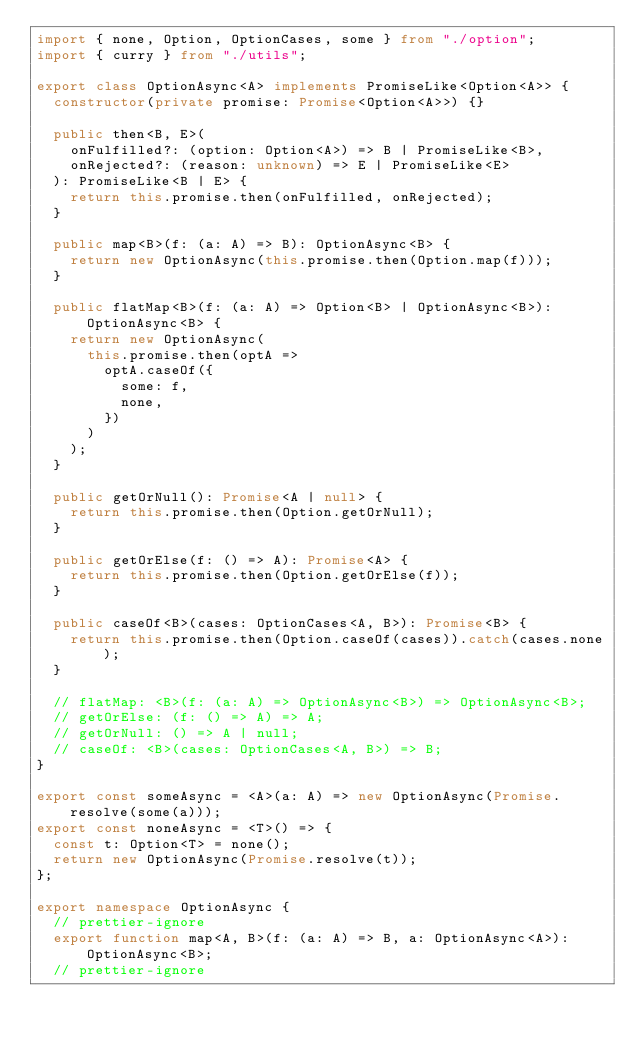Convert code to text. <code><loc_0><loc_0><loc_500><loc_500><_TypeScript_>import { none, Option, OptionCases, some } from "./option";
import { curry } from "./utils";

export class OptionAsync<A> implements PromiseLike<Option<A>> {
  constructor(private promise: Promise<Option<A>>) {}

  public then<B, E>(
    onFulfilled?: (option: Option<A>) => B | PromiseLike<B>,
    onRejected?: (reason: unknown) => E | PromiseLike<E>
  ): PromiseLike<B | E> {
    return this.promise.then(onFulfilled, onRejected);
  }

  public map<B>(f: (a: A) => B): OptionAsync<B> {
    return new OptionAsync(this.promise.then(Option.map(f)));
  }

  public flatMap<B>(f: (a: A) => Option<B> | OptionAsync<B>): OptionAsync<B> {
    return new OptionAsync(
      this.promise.then(optA =>
        optA.caseOf({
          some: f,
          none,
        })
      )
    );
  }

  public getOrNull(): Promise<A | null> {
    return this.promise.then(Option.getOrNull);
  }

  public getOrElse(f: () => A): Promise<A> {
    return this.promise.then(Option.getOrElse(f));
  }

  public caseOf<B>(cases: OptionCases<A, B>): Promise<B> {
    return this.promise.then(Option.caseOf(cases)).catch(cases.none);
  }

  // flatMap: <B>(f: (a: A) => OptionAsync<B>) => OptionAsync<B>;
  // getOrElse: (f: () => A) => A;
  // getOrNull: () => A | null;
  // caseOf: <B>(cases: OptionCases<A, B>) => B;
}

export const someAsync = <A>(a: A) => new OptionAsync(Promise.resolve(some(a)));
export const noneAsync = <T>() => {
  const t: Option<T> = none();
  return new OptionAsync(Promise.resolve(t));
};

export namespace OptionAsync {
  // prettier-ignore
  export function map<A, B>(f: (a: A) => B, a: OptionAsync<A>): OptionAsync<B>;
  // prettier-ignore</code> 